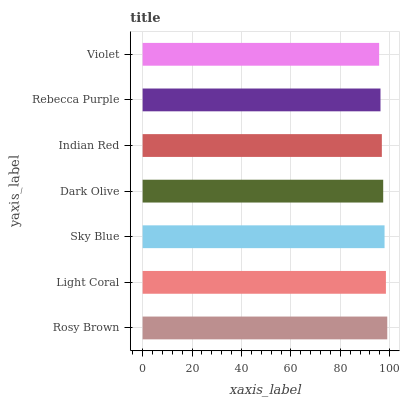Is Violet the minimum?
Answer yes or no. Yes. Is Rosy Brown the maximum?
Answer yes or no. Yes. Is Light Coral the minimum?
Answer yes or no. No. Is Light Coral the maximum?
Answer yes or no. No. Is Rosy Brown greater than Light Coral?
Answer yes or no. Yes. Is Light Coral less than Rosy Brown?
Answer yes or no. Yes. Is Light Coral greater than Rosy Brown?
Answer yes or no. No. Is Rosy Brown less than Light Coral?
Answer yes or no. No. Is Dark Olive the high median?
Answer yes or no. Yes. Is Dark Olive the low median?
Answer yes or no. Yes. Is Violet the high median?
Answer yes or no. No. Is Rosy Brown the low median?
Answer yes or no. No. 